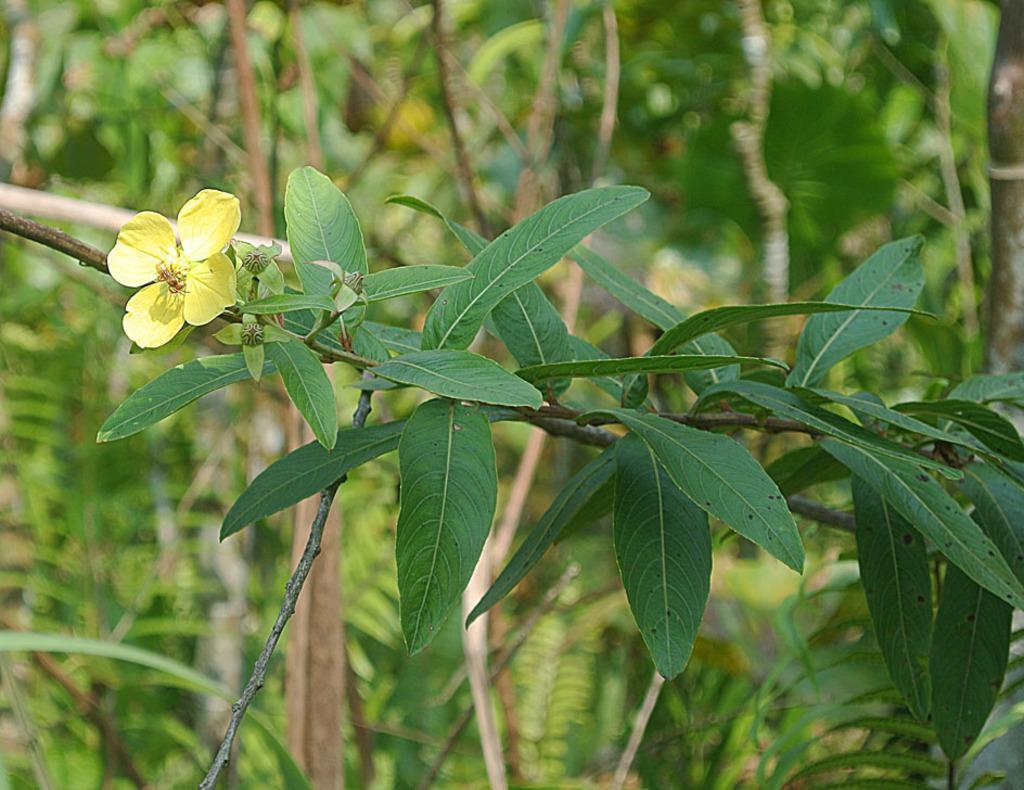Please provide a concise description of this image. In the image we can see a flower, yellow in color and there are leaves. The background is blurred. 